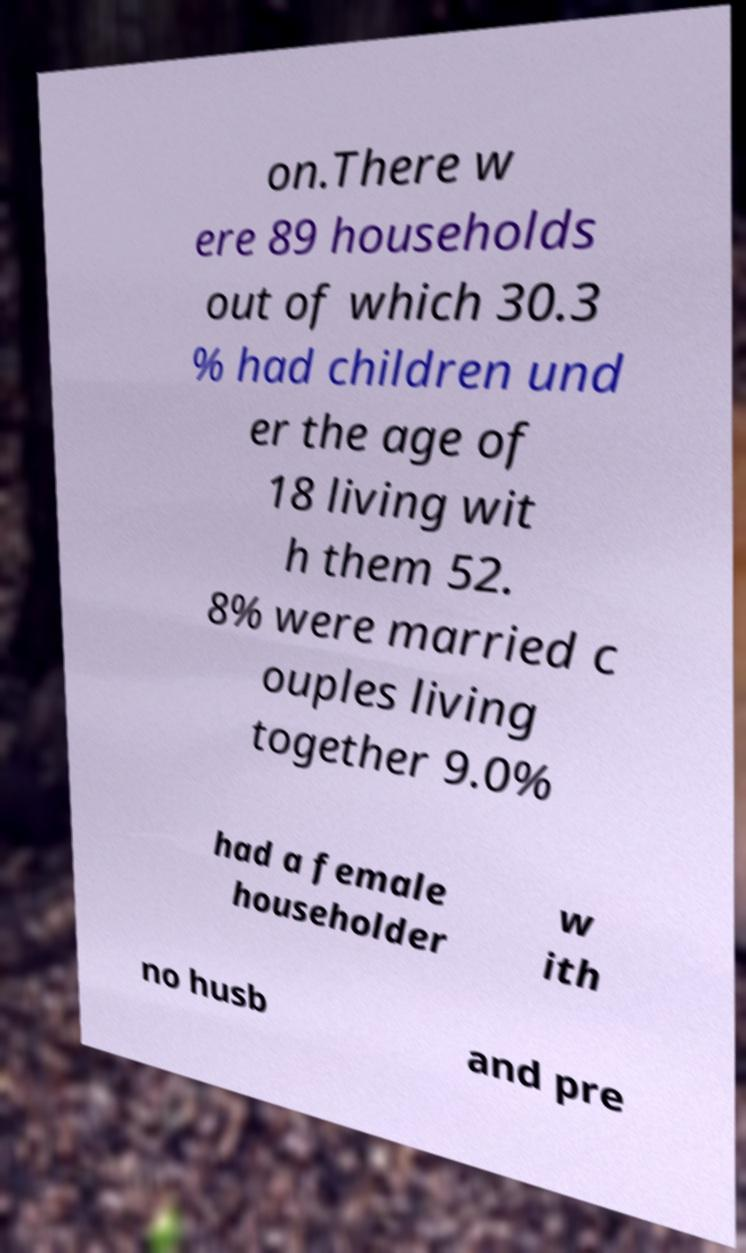For documentation purposes, I need the text within this image transcribed. Could you provide that? on.There w ere 89 households out of which 30.3 % had children und er the age of 18 living wit h them 52. 8% were married c ouples living together 9.0% had a female householder w ith no husb and pre 